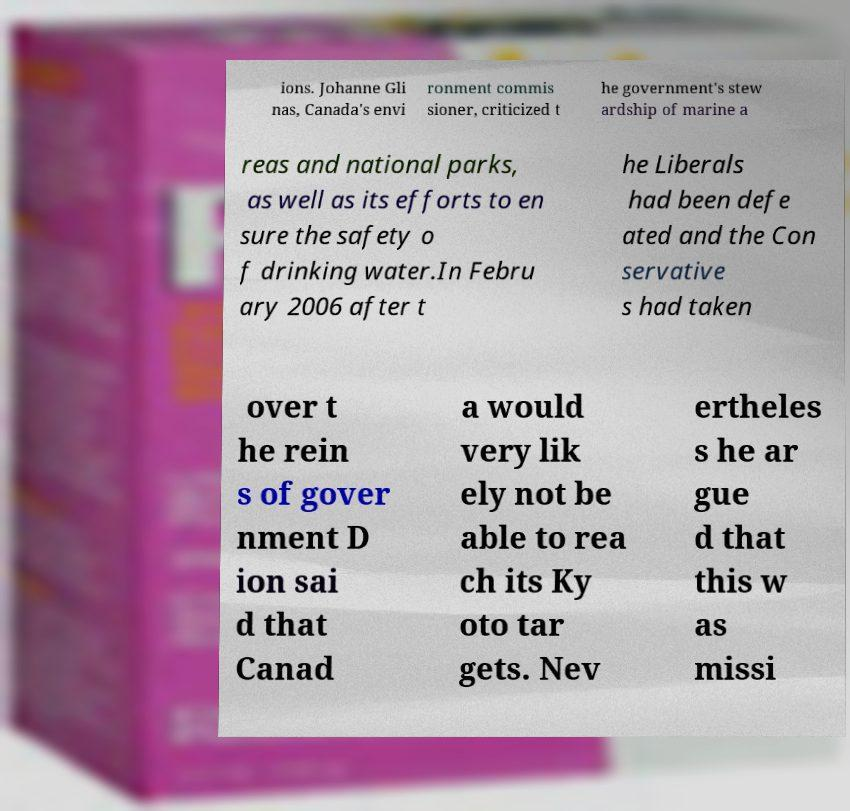Can you read and provide the text displayed in the image?This photo seems to have some interesting text. Can you extract and type it out for me? ions. Johanne Gli nas, Canada's envi ronment commis sioner, criticized t he government's stew ardship of marine a reas and national parks, as well as its efforts to en sure the safety o f drinking water.In Febru ary 2006 after t he Liberals had been defe ated and the Con servative s had taken over t he rein s of gover nment D ion sai d that Canad a would very lik ely not be able to rea ch its Ky oto tar gets. Nev ertheles s he ar gue d that this w as missi 